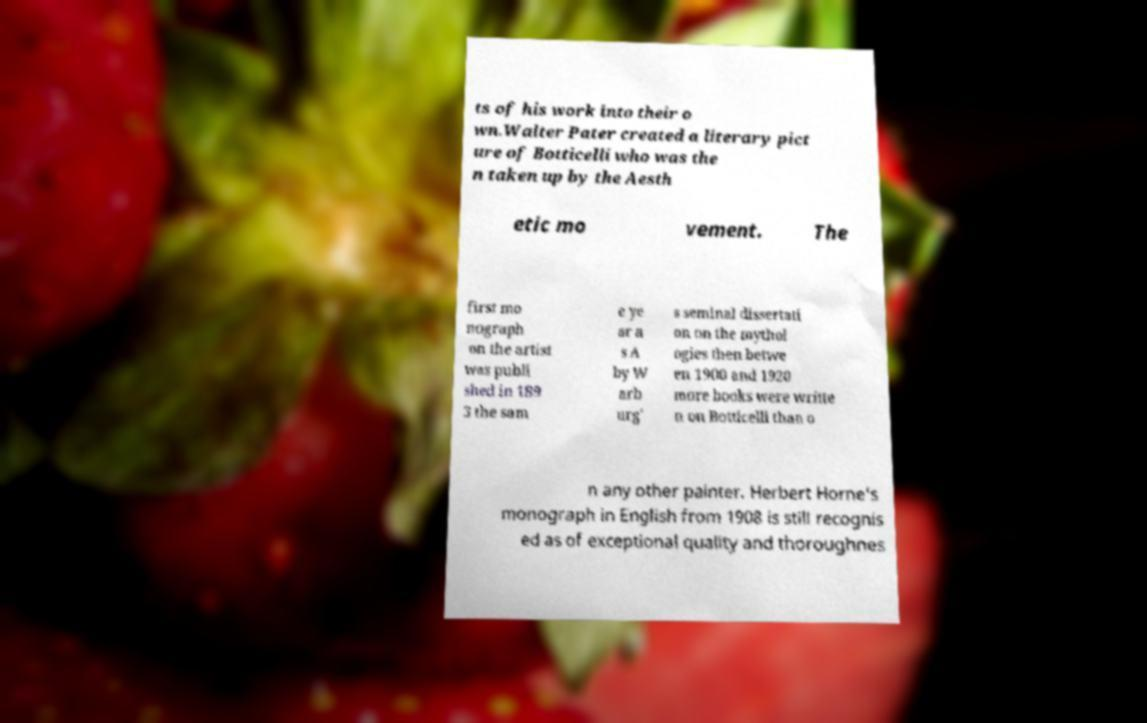Can you accurately transcribe the text from the provided image for me? ts of his work into their o wn.Walter Pater created a literary pict ure of Botticelli who was the n taken up by the Aesth etic mo vement. The first mo nograph on the artist was publi shed in 189 3 the sam e ye ar a s A by W arb urg' s seminal dissertati on on the mythol ogies then betwe en 1900 and 1920 more books were writte n on Botticelli than o n any other painter. Herbert Horne's monograph in English from 1908 is still recognis ed as of exceptional quality and thoroughnes 